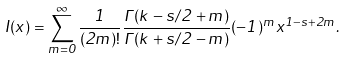Convert formula to latex. <formula><loc_0><loc_0><loc_500><loc_500>I ( x ) = \sum _ { m = 0 } ^ { \infty } \frac { 1 } { ( 2 m ) ! } \frac { \Gamma ( k - s / 2 + m ) } { \Gamma ( k + s / 2 - m ) } ( - 1 ) ^ { m } x ^ { 1 - s + 2 m } .</formula> 